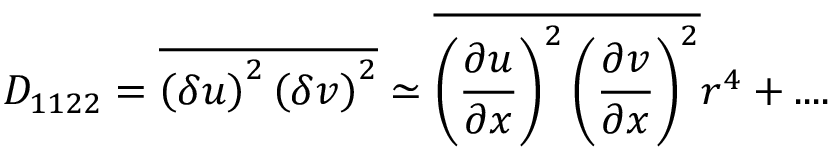<formula> <loc_0><loc_0><loc_500><loc_500>D _ { 1 1 2 2 } = \overline { { \left ( \delta u \right ) ^ { 2 } \left ( \delta v \right ) ^ { 2 } } } \simeq \overline { { \left ( \frac { \partial u } { \partial x } \right ) ^ { 2 } \left ( \frac { \partial v } { \partial x } \right ) ^ { 2 } } } r ^ { 4 } + \cdots</formula> 